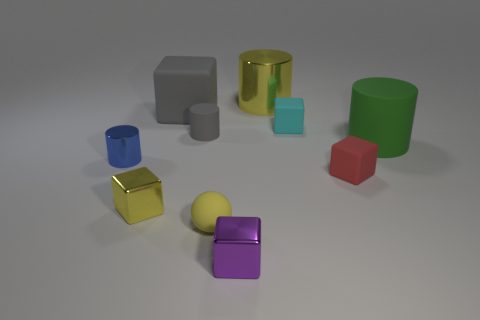How could these objects be used in an educational context? In an educational context, these objects could be used to teach children about geometry, colors, and materials. For instance, an educator might ask students to identify and categorize the objects by shape—cubes, cylinders, and spheres—or by color, enhancing their visual recognition and cognitive skills. 